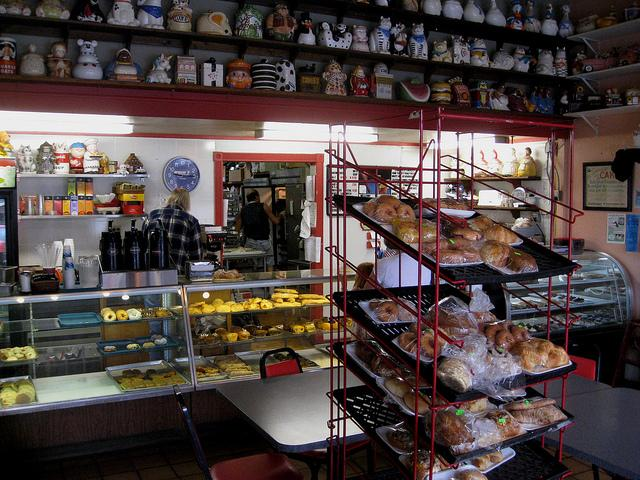What type of items are on the rack in front?

Choices:
A) raw
B) day old
C) overdone
D) freshest day old 